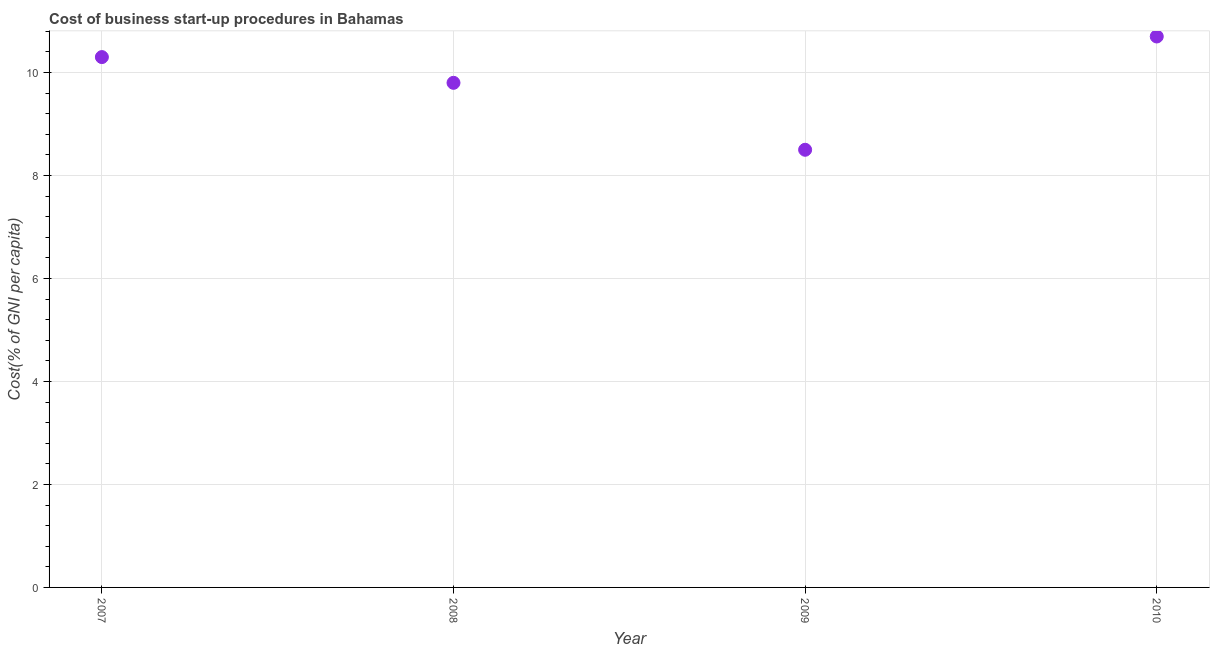Across all years, what is the maximum cost of business startup procedures?
Provide a succinct answer. 10.7. Across all years, what is the minimum cost of business startup procedures?
Give a very brief answer. 8.5. What is the sum of the cost of business startup procedures?
Keep it short and to the point. 39.3. What is the difference between the cost of business startup procedures in 2007 and 2010?
Keep it short and to the point. -0.4. What is the average cost of business startup procedures per year?
Provide a short and direct response. 9.82. What is the median cost of business startup procedures?
Provide a succinct answer. 10.05. What is the ratio of the cost of business startup procedures in 2007 to that in 2010?
Your answer should be very brief. 0.96. Is the cost of business startup procedures in 2007 less than that in 2008?
Ensure brevity in your answer.  No. What is the difference between the highest and the second highest cost of business startup procedures?
Offer a very short reply. 0.4. Is the sum of the cost of business startup procedures in 2008 and 2010 greater than the maximum cost of business startup procedures across all years?
Offer a terse response. Yes. What is the difference between the highest and the lowest cost of business startup procedures?
Provide a short and direct response. 2.2. How many years are there in the graph?
Offer a terse response. 4. What is the difference between two consecutive major ticks on the Y-axis?
Your answer should be very brief. 2. What is the title of the graph?
Your answer should be compact. Cost of business start-up procedures in Bahamas. What is the label or title of the Y-axis?
Your response must be concise. Cost(% of GNI per capita). What is the Cost(% of GNI per capita) in 2007?
Provide a succinct answer. 10.3. What is the difference between the Cost(% of GNI per capita) in 2008 and 2010?
Provide a succinct answer. -0.9. What is the ratio of the Cost(% of GNI per capita) in 2007 to that in 2008?
Make the answer very short. 1.05. What is the ratio of the Cost(% of GNI per capita) in 2007 to that in 2009?
Provide a succinct answer. 1.21. What is the ratio of the Cost(% of GNI per capita) in 2008 to that in 2009?
Provide a succinct answer. 1.15. What is the ratio of the Cost(% of GNI per capita) in 2008 to that in 2010?
Your response must be concise. 0.92. What is the ratio of the Cost(% of GNI per capita) in 2009 to that in 2010?
Make the answer very short. 0.79. 